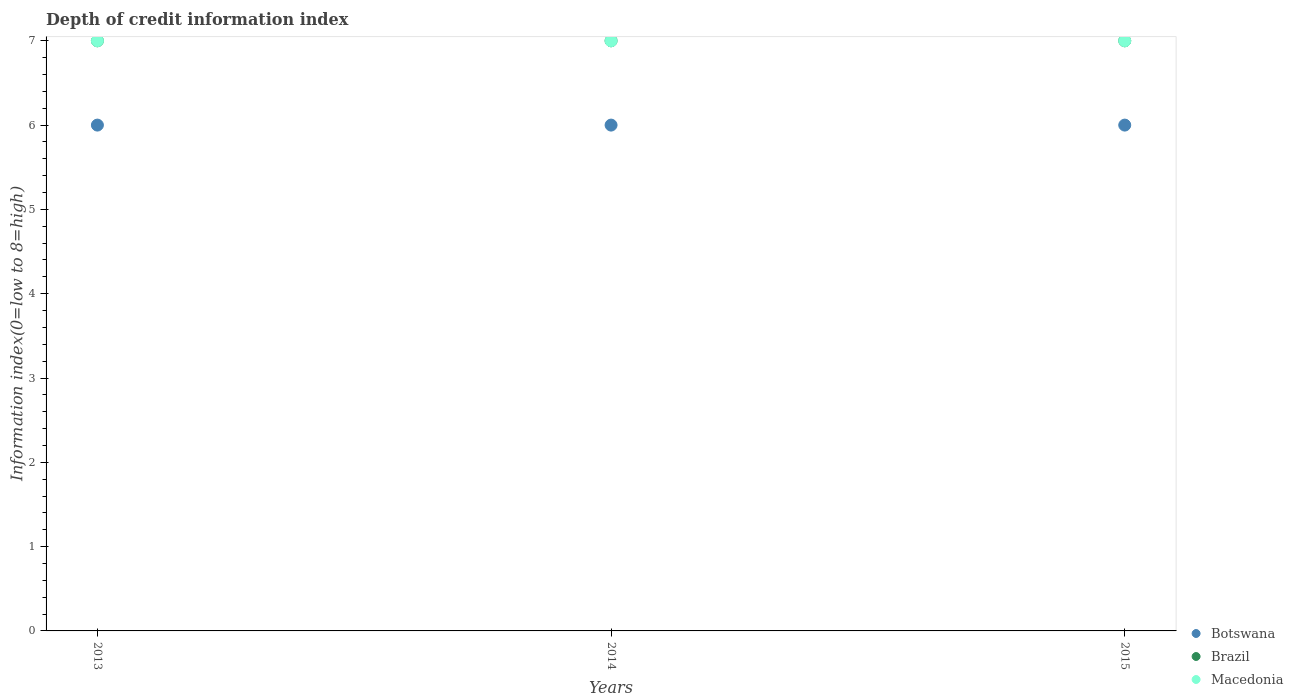Is the number of dotlines equal to the number of legend labels?
Your answer should be very brief. Yes. What is the information index in Macedonia in 2013?
Provide a succinct answer. 7. Across all years, what is the maximum information index in Botswana?
Offer a terse response. 6. Across all years, what is the minimum information index in Botswana?
Your answer should be compact. 6. In which year was the information index in Macedonia minimum?
Provide a succinct answer. 2013. What is the total information index in Botswana in the graph?
Make the answer very short. 18. What is the average information index in Macedonia per year?
Make the answer very short. 7. In the year 2013, what is the difference between the information index in Brazil and information index in Macedonia?
Your answer should be compact. 0. Is the difference between the information index in Brazil in 2013 and 2014 greater than the difference between the information index in Macedonia in 2013 and 2014?
Your answer should be very brief. No. What is the difference between the highest and the second highest information index in Macedonia?
Offer a terse response. 0. What is the difference between the highest and the lowest information index in Brazil?
Your answer should be very brief. 0. Is the sum of the information index in Macedonia in 2013 and 2014 greater than the maximum information index in Brazil across all years?
Your response must be concise. Yes. Is it the case that in every year, the sum of the information index in Macedonia and information index in Brazil  is greater than the information index in Botswana?
Keep it short and to the point. Yes. Does the information index in Brazil monotonically increase over the years?
Offer a very short reply. No. How many dotlines are there?
Give a very brief answer. 3. What is the difference between two consecutive major ticks on the Y-axis?
Your answer should be compact. 1. Does the graph contain any zero values?
Provide a succinct answer. No. Where does the legend appear in the graph?
Offer a very short reply. Bottom right. What is the title of the graph?
Provide a short and direct response. Depth of credit information index. What is the label or title of the Y-axis?
Your answer should be very brief. Information index(0=low to 8=high). What is the Information index(0=low to 8=high) in Brazil in 2013?
Offer a terse response. 7. What is the Information index(0=low to 8=high) of Macedonia in 2013?
Offer a terse response. 7. What is the Information index(0=low to 8=high) of Botswana in 2014?
Your answer should be compact. 6. What is the Information index(0=low to 8=high) of Brazil in 2014?
Keep it short and to the point. 7. What is the Information index(0=low to 8=high) of Macedonia in 2014?
Provide a succinct answer. 7. What is the Information index(0=low to 8=high) in Botswana in 2015?
Offer a terse response. 6. Across all years, what is the minimum Information index(0=low to 8=high) of Botswana?
Provide a short and direct response. 6. What is the total Information index(0=low to 8=high) in Botswana in the graph?
Make the answer very short. 18. What is the total Information index(0=low to 8=high) of Brazil in the graph?
Provide a succinct answer. 21. What is the difference between the Information index(0=low to 8=high) in Botswana in 2013 and that in 2014?
Give a very brief answer. 0. What is the difference between the Information index(0=low to 8=high) of Brazil in 2013 and that in 2014?
Your answer should be compact. 0. What is the difference between the Information index(0=low to 8=high) in Macedonia in 2013 and that in 2015?
Offer a terse response. 0. What is the difference between the Information index(0=low to 8=high) of Botswana in 2014 and that in 2015?
Make the answer very short. 0. What is the difference between the Information index(0=low to 8=high) in Macedonia in 2014 and that in 2015?
Offer a very short reply. 0. What is the difference between the Information index(0=low to 8=high) in Brazil in 2013 and the Information index(0=low to 8=high) in Macedonia in 2014?
Your answer should be very brief. 0. What is the difference between the Information index(0=low to 8=high) of Botswana in 2014 and the Information index(0=low to 8=high) of Macedonia in 2015?
Offer a very short reply. -1. What is the difference between the Information index(0=low to 8=high) in Brazil in 2014 and the Information index(0=low to 8=high) in Macedonia in 2015?
Make the answer very short. 0. What is the average Information index(0=low to 8=high) of Botswana per year?
Offer a terse response. 6. What is the average Information index(0=low to 8=high) in Macedonia per year?
Give a very brief answer. 7. In the year 2013, what is the difference between the Information index(0=low to 8=high) of Botswana and Information index(0=low to 8=high) of Brazil?
Offer a terse response. -1. In the year 2013, what is the difference between the Information index(0=low to 8=high) of Botswana and Information index(0=low to 8=high) of Macedonia?
Offer a terse response. -1. In the year 2014, what is the difference between the Information index(0=low to 8=high) in Botswana and Information index(0=low to 8=high) in Brazil?
Provide a short and direct response. -1. In the year 2014, what is the difference between the Information index(0=low to 8=high) of Botswana and Information index(0=low to 8=high) of Macedonia?
Give a very brief answer. -1. In the year 2015, what is the difference between the Information index(0=low to 8=high) of Brazil and Information index(0=low to 8=high) of Macedonia?
Provide a succinct answer. 0. What is the ratio of the Information index(0=low to 8=high) of Macedonia in 2013 to that in 2014?
Your response must be concise. 1. What is the ratio of the Information index(0=low to 8=high) in Botswana in 2013 to that in 2015?
Your answer should be compact. 1. What is the ratio of the Information index(0=low to 8=high) of Brazil in 2013 to that in 2015?
Ensure brevity in your answer.  1. What is the ratio of the Information index(0=low to 8=high) in Macedonia in 2013 to that in 2015?
Your response must be concise. 1. What is the ratio of the Information index(0=low to 8=high) of Botswana in 2014 to that in 2015?
Provide a succinct answer. 1. What is the ratio of the Information index(0=low to 8=high) in Brazil in 2014 to that in 2015?
Keep it short and to the point. 1. What is the difference between the highest and the second highest Information index(0=low to 8=high) of Botswana?
Offer a terse response. 0. What is the difference between the highest and the second highest Information index(0=low to 8=high) in Macedonia?
Your response must be concise. 0. What is the difference between the highest and the lowest Information index(0=low to 8=high) of Macedonia?
Keep it short and to the point. 0. 